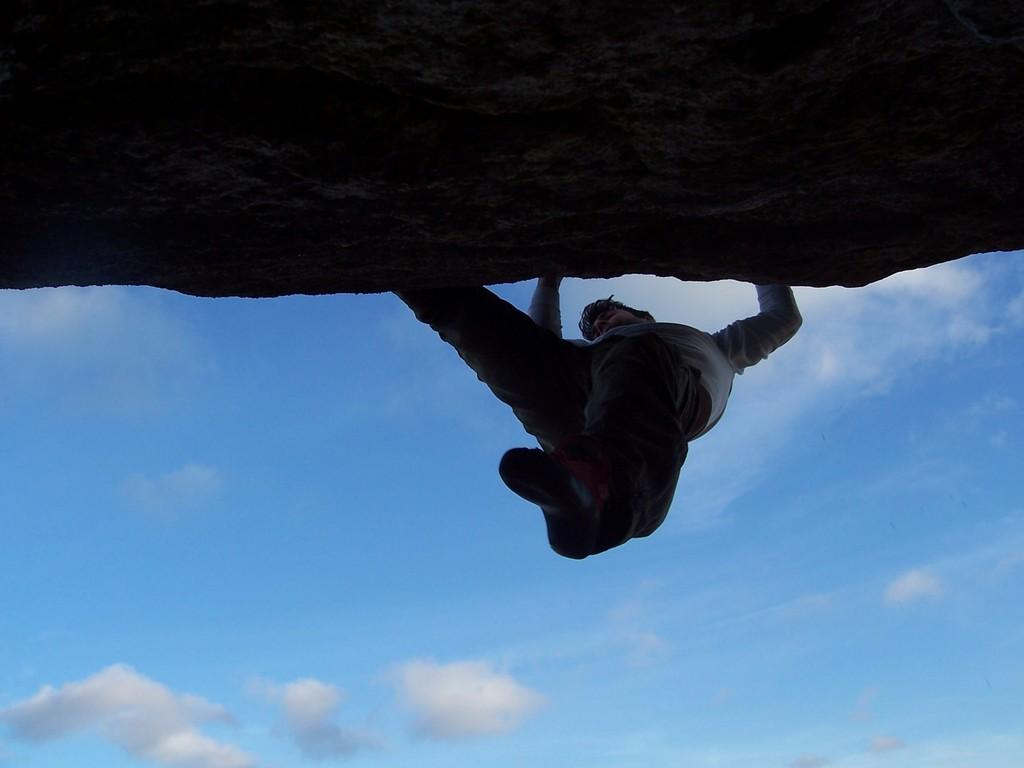What is happening in the image? There is a person in the image who is climbing a hill. What can be seen in the sky at the bottom of the image? Clouds are present in the sky at the bottom of the image. What time is displayed on the clock in the image? There is no clock present in the image. What degree of difficulty is the person facing while climbing the hill? The degree of difficulty cannot be determined from the image alone, as it does not provide information about the steepness or terrain of the hill. 